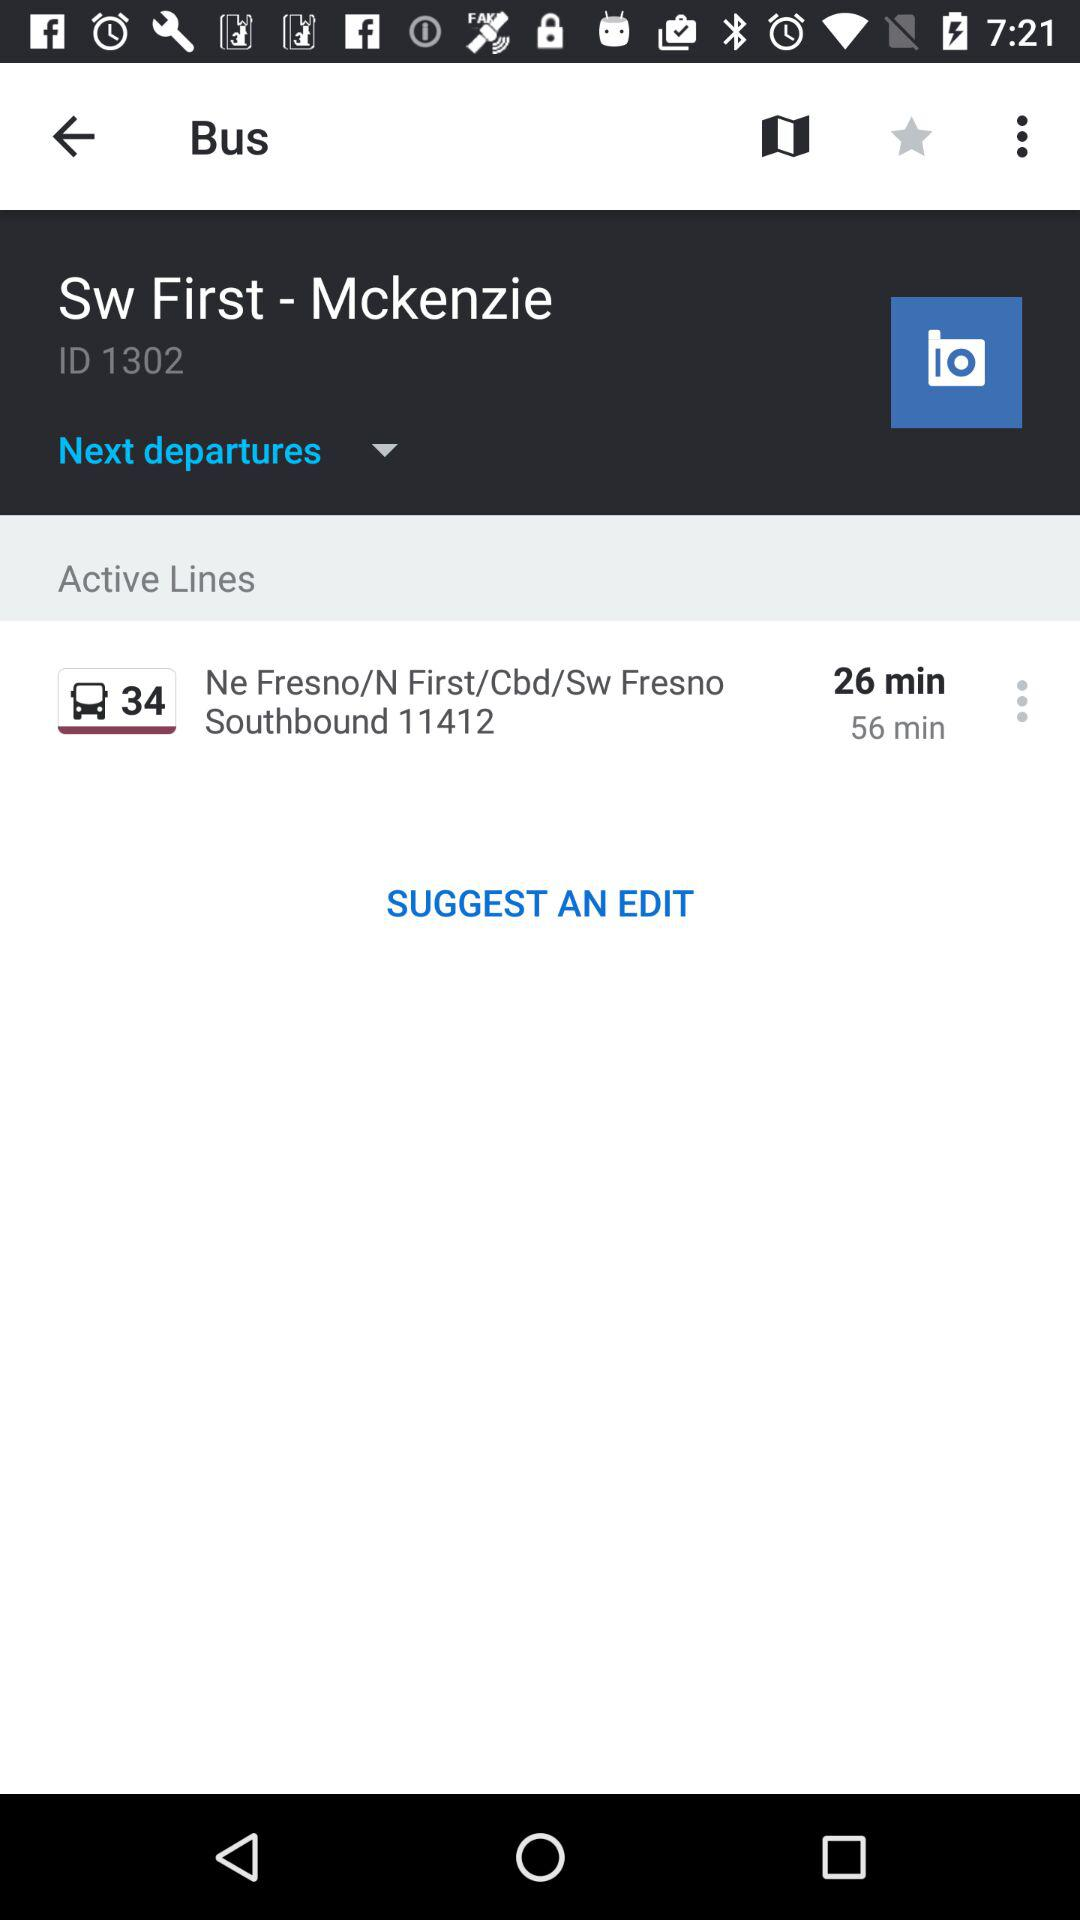Where is it from?
When the provided information is insufficient, respond with <no answer>. <no answer> 